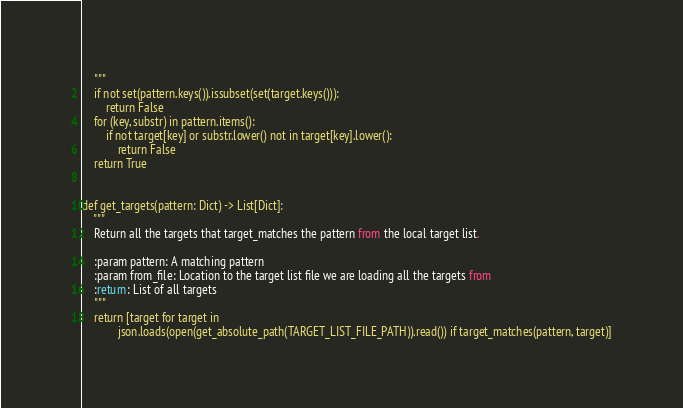<code> <loc_0><loc_0><loc_500><loc_500><_Python_>    """
    if not set(pattern.keys()).issubset(set(target.keys())):
        return False
    for (key, substr) in pattern.items():
        if not target[key] or substr.lower() not in target[key].lower():
            return False
    return True


def get_targets(pattern: Dict) -> List[Dict]:
    """
    Return all the targets that target_matches the pattern from the local target list.

    :param pattern: A matching pattern
    :param from_file: Location to the target list file we are loading all the targets from
    :return: List of all targets
    """
    return [target for target in
            json.loads(open(get_absolute_path(TARGET_LIST_FILE_PATH)).read()) if target_matches(pattern, target)]
</code> 